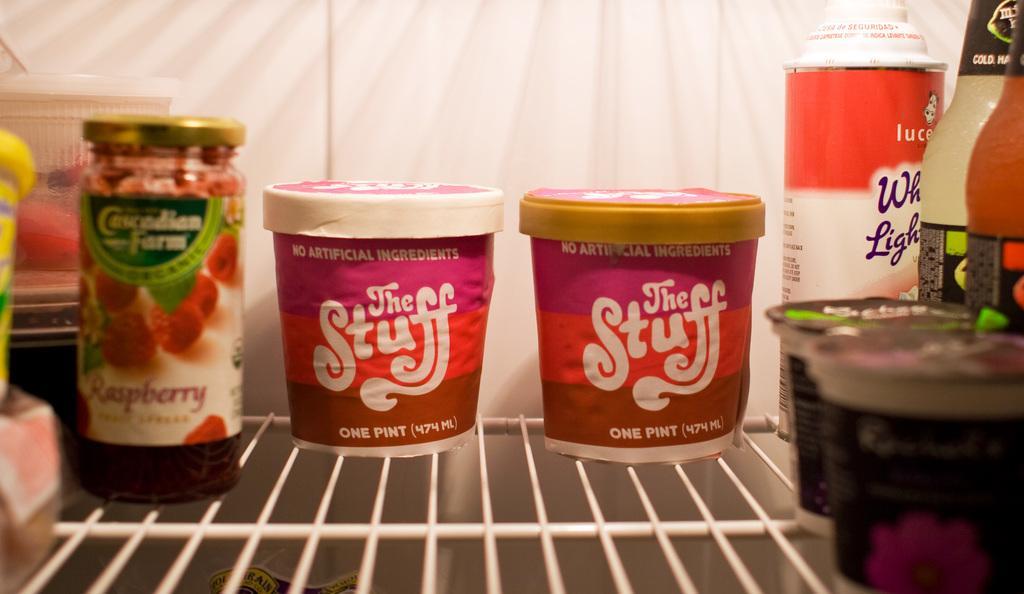In one or two sentences, can you explain what this image depicts? This is a zoomed in picture. On the right corner we can see the bottles of drinks. In the center we can see the containers and a jar of food items and we can see the text on the containers. The background of the image is white in color. 